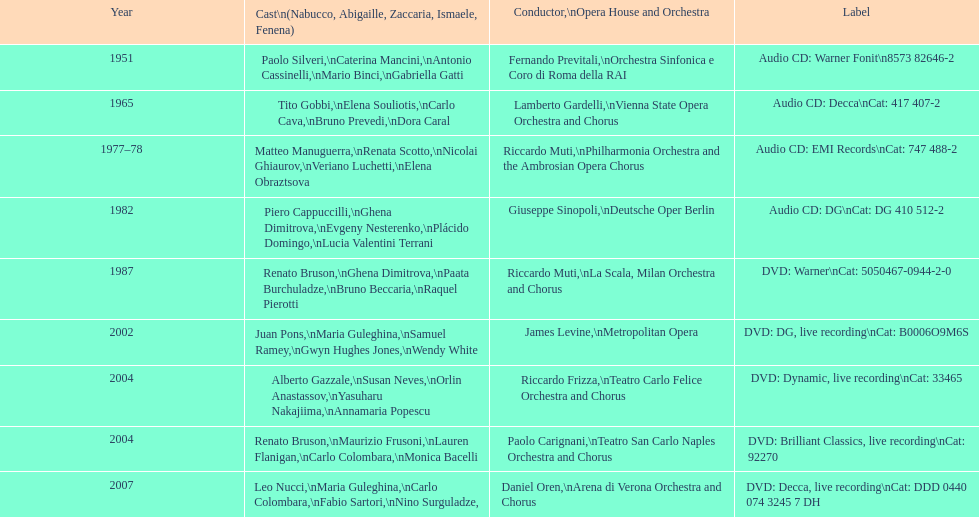How many recordings of nabucco have been made? 9. 